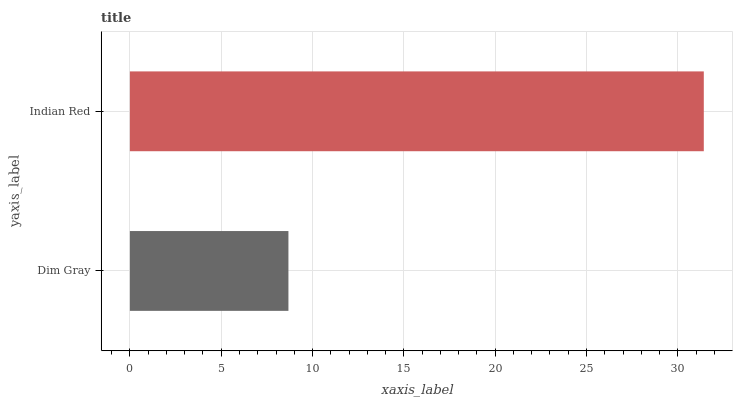Is Dim Gray the minimum?
Answer yes or no. Yes. Is Indian Red the maximum?
Answer yes or no. Yes. Is Indian Red the minimum?
Answer yes or no. No. Is Indian Red greater than Dim Gray?
Answer yes or no. Yes. Is Dim Gray less than Indian Red?
Answer yes or no. Yes. Is Dim Gray greater than Indian Red?
Answer yes or no. No. Is Indian Red less than Dim Gray?
Answer yes or no. No. Is Indian Red the high median?
Answer yes or no. Yes. Is Dim Gray the low median?
Answer yes or no. Yes. Is Dim Gray the high median?
Answer yes or no. No. Is Indian Red the low median?
Answer yes or no. No. 